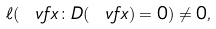<formula> <loc_0><loc_0><loc_500><loc_500>\ell ( \ v f x \colon D ( \ v f x ) = 0 ) \not = 0 ,</formula> 